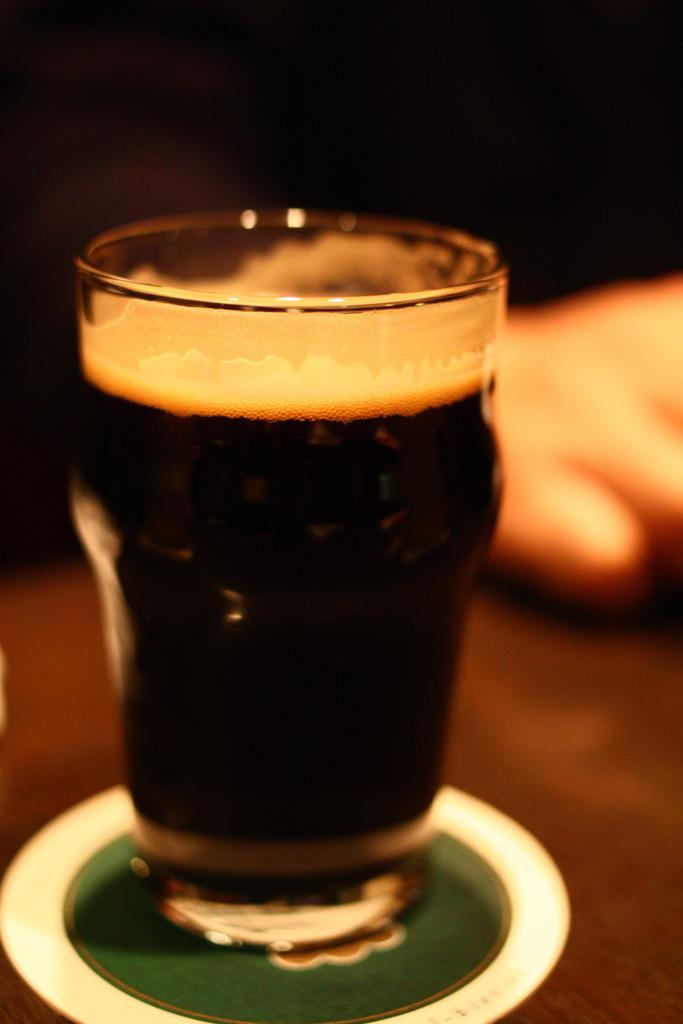What is on the plate in the image? There is a glass on a plate in the image. What is inside the glass? The glass is filled with a drink. Where is the plate located? The plate is placed on a table. Whose hand is visible in the image? A person's hand is visible on the right side of the image. What type of creature is interacting with the glass on the plate in the image? There is no creature present in the image; it only shows a glass on a plate, a drink inside the glass, and a person's hand. How does the zephyr affect the glass on the plate in the image? There is no mention of a zephyr or any wind in the image; the glass is stationary on the plate. 